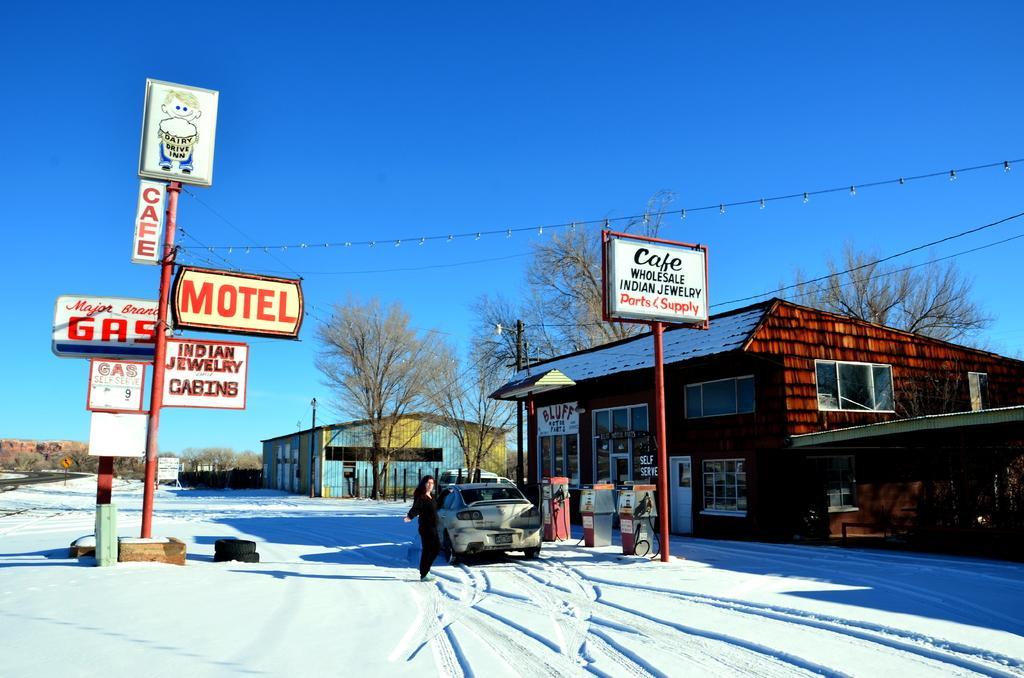Can you describe this image briefly? In the image we can see everywhere there is a snow, white in color. We can even see a vehicle and a person standing, wearing clothes. Here we can see electric wires, poles and boards. We can see houses, electric poles, trees and the sky. 